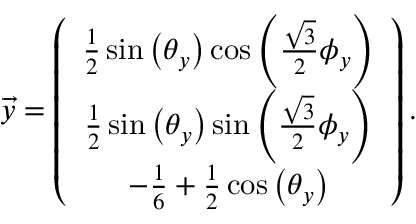Convert formula to latex. <formula><loc_0><loc_0><loc_500><loc_500>\begin{array} { r } { \overrightarrow { y } = \left ( \begin{array} { c } { \frac { 1 } { 2 } \sin \left ( \theta _ { y } \right ) \cos \left ( \frac { \sqrt { 3 } } { 2 } \phi _ { y } \right ) } \\ { \frac { 1 } { 2 } \sin \left ( \theta _ { y } \right ) \sin \left ( \frac { \sqrt { 3 } } { 2 } \phi _ { y } \right ) } \\ { - \frac { 1 } { 6 } + \frac { 1 } { 2 } \cos \left ( \theta _ { y } \right ) } \end{array} \right ) . } \end{array}</formula> 